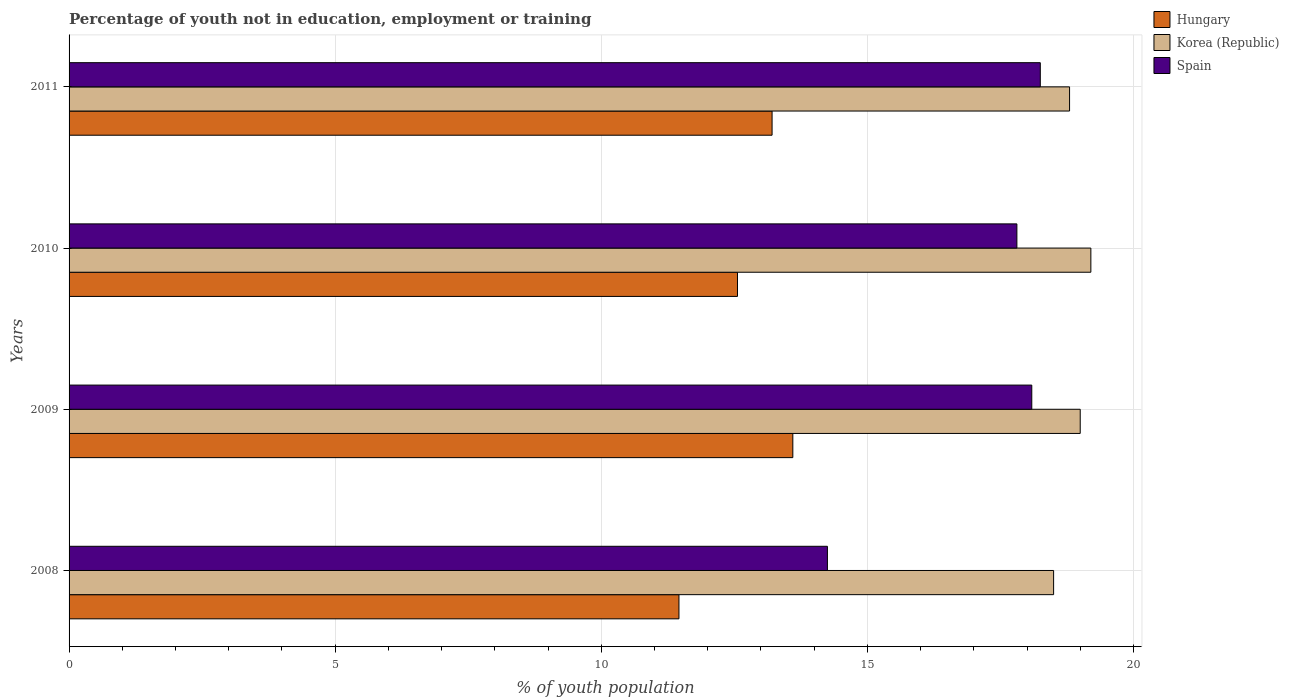How many different coloured bars are there?
Provide a short and direct response. 3. How many groups of bars are there?
Make the answer very short. 4. Are the number of bars per tick equal to the number of legend labels?
Provide a short and direct response. Yes. What is the label of the 2nd group of bars from the top?
Provide a succinct answer. 2010. In how many cases, is the number of bars for a given year not equal to the number of legend labels?
Provide a short and direct response. 0. Across all years, what is the maximum percentage of unemployed youth population in in Hungary?
Offer a very short reply. 13.6. Across all years, what is the minimum percentage of unemployed youth population in in Spain?
Your answer should be compact. 14.25. In which year was the percentage of unemployed youth population in in Spain minimum?
Offer a very short reply. 2008. What is the total percentage of unemployed youth population in in Korea (Republic) in the graph?
Offer a terse response. 75.5. What is the difference between the percentage of unemployed youth population in in Hungary in 2009 and that in 2011?
Your answer should be compact. 0.39. What is the difference between the percentage of unemployed youth population in in Hungary in 2010 and the percentage of unemployed youth population in in Korea (Republic) in 2008?
Provide a short and direct response. -5.94. What is the average percentage of unemployed youth population in in Spain per year?
Keep it short and to the point. 17.1. In the year 2011, what is the difference between the percentage of unemployed youth population in in Hungary and percentage of unemployed youth population in in Korea (Republic)?
Your answer should be very brief. -5.59. In how many years, is the percentage of unemployed youth population in in Spain greater than 15 %?
Keep it short and to the point. 3. What is the ratio of the percentage of unemployed youth population in in Hungary in 2008 to that in 2011?
Offer a very short reply. 0.87. Is the percentage of unemployed youth population in in Hungary in 2008 less than that in 2009?
Offer a very short reply. Yes. What is the difference between the highest and the second highest percentage of unemployed youth population in in Spain?
Your answer should be compact. 0.16. What is the difference between the highest and the lowest percentage of unemployed youth population in in Hungary?
Provide a short and direct response. 2.14. What does the 3rd bar from the top in 2008 represents?
Provide a short and direct response. Hungary. What does the 3rd bar from the bottom in 2008 represents?
Give a very brief answer. Spain. How many bars are there?
Make the answer very short. 12. Are all the bars in the graph horizontal?
Offer a terse response. Yes. How many years are there in the graph?
Provide a succinct answer. 4. Does the graph contain grids?
Your response must be concise. Yes. How many legend labels are there?
Offer a very short reply. 3. How are the legend labels stacked?
Offer a terse response. Vertical. What is the title of the graph?
Provide a short and direct response. Percentage of youth not in education, employment or training. Does "French Polynesia" appear as one of the legend labels in the graph?
Offer a very short reply. No. What is the label or title of the X-axis?
Provide a succinct answer. % of youth population. What is the % of youth population of Hungary in 2008?
Make the answer very short. 11.46. What is the % of youth population in Korea (Republic) in 2008?
Keep it short and to the point. 18.5. What is the % of youth population in Spain in 2008?
Give a very brief answer. 14.25. What is the % of youth population of Hungary in 2009?
Your response must be concise. 13.6. What is the % of youth population in Korea (Republic) in 2009?
Give a very brief answer. 19. What is the % of youth population of Spain in 2009?
Keep it short and to the point. 18.09. What is the % of youth population of Hungary in 2010?
Make the answer very short. 12.56. What is the % of youth population in Korea (Republic) in 2010?
Your response must be concise. 19.2. What is the % of youth population in Spain in 2010?
Your answer should be very brief. 17.81. What is the % of youth population of Hungary in 2011?
Your response must be concise. 13.21. What is the % of youth population of Korea (Republic) in 2011?
Ensure brevity in your answer.  18.8. What is the % of youth population in Spain in 2011?
Give a very brief answer. 18.25. Across all years, what is the maximum % of youth population of Hungary?
Provide a succinct answer. 13.6. Across all years, what is the maximum % of youth population of Korea (Republic)?
Your response must be concise. 19.2. Across all years, what is the maximum % of youth population in Spain?
Make the answer very short. 18.25. Across all years, what is the minimum % of youth population of Hungary?
Your answer should be very brief. 11.46. Across all years, what is the minimum % of youth population of Spain?
Your answer should be very brief. 14.25. What is the total % of youth population of Hungary in the graph?
Give a very brief answer. 50.83. What is the total % of youth population in Korea (Republic) in the graph?
Make the answer very short. 75.5. What is the total % of youth population of Spain in the graph?
Your answer should be compact. 68.4. What is the difference between the % of youth population in Hungary in 2008 and that in 2009?
Your answer should be compact. -2.14. What is the difference between the % of youth population of Spain in 2008 and that in 2009?
Offer a terse response. -3.84. What is the difference between the % of youth population in Hungary in 2008 and that in 2010?
Your answer should be very brief. -1.1. What is the difference between the % of youth population in Korea (Republic) in 2008 and that in 2010?
Make the answer very short. -0.7. What is the difference between the % of youth population of Spain in 2008 and that in 2010?
Ensure brevity in your answer.  -3.56. What is the difference between the % of youth population in Hungary in 2008 and that in 2011?
Give a very brief answer. -1.75. What is the difference between the % of youth population in Korea (Republic) in 2008 and that in 2011?
Provide a short and direct response. -0.3. What is the difference between the % of youth population of Spain in 2008 and that in 2011?
Keep it short and to the point. -4. What is the difference between the % of youth population of Korea (Republic) in 2009 and that in 2010?
Make the answer very short. -0.2. What is the difference between the % of youth population of Spain in 2009 and that in 2010?
Provide a succinct answer. 0.28. What is the difference between the % of youth population of Hungary in 2009 and that in 2011?
Ensure brevity in your answer.  0.39. What is the difference between the % of youth population in Spain in 2009 and that in 2011?
Provide a short and direct response. -0.16. What is the difference between the % of youth population of Hungary in 2010 and that in 2011?
Ensure brevity in your answer.  -0.65. What is the difference between the % of youth population in Korea (Republic) in 2010 and that in 2011?
Offer a terse response. 0.4. What is the difference between the % of youth population of Spain in 2010 and that in 2011?
Your response must be concise. -0.44. What is the difference between the % of youth population of Hungary in 2008 and the % of youth population of Korea (Republic) in 2009?
Your response must be concise. -7.54. What is the difference between the % of youth population of Hungary in 2008 and the % of youth population of Spain in 2009?
Provide a short and direct response. -6.63. What is the difference between the % of youth population in Korea (Republic) in 2008 and the % of youth population in Spain in 2009?
Your answer should be very brief. 0.41. What is the difference between the % of youth population in Hungary in 2008 and the % of youth population in Korea (Republic) in 2010?
Make the answer very short. -7.74. What is the difference between the % of youth population of Hungary in 2008 and the % of youth population of Spain in 2010?
Offer a terse response. -6.35. What is the difference between the % of youth population of Korea (Republic) in 2008 and the % of youth population of Spain in 2010?
Provide a short and direct response. 0.69. What is the difference between the % of youth population in Hungary in 2008 and the % of youth population in Korea (Republic) in 2011?
Provide a succinct answer. -7.34. What is the difference between the % of youth population of Hungary in 2008 and the % of youth population of Spain in 2011?
Keep it short and to the point. -6.79. What is the difference between the % of youth population of Hungary in 2009 and the % of youth population of Spain in 2010?
Provide a short and direct response. -4.21. What is the difference between the % of youth population of Korea (Republic) in 2009 and the % of youth population of Spain in 2010?
Give a very brief answer. 1.19. What is the difference between the % of youth population of Hungary in 2009 and the % of youth population of Korea (Republic) in 2011?
Provide a succinct answer. -5.2. What is the difference between the % of youth population in Hungary in 2009 and the % of youth population in Spain in 2011?
Make the answer very short. -4.65. What is the difference between the % of youth population in Korea (Republic) in 2009 and the % of youth population in Spain in 2011?
Ensure brevity in your answer.  0.75. What is the difference between the % of youth population of Hungary in 2010 and the % of youth population of Korea (Republic) in 2011?
Give a very brief answer. -6.24. What is the difference between the % of youth population in Hungary in 2010 and the % of youth population in Spain in 2011?
Your answer should be compact. -5.69. What is the average % of youth population in Hungary per year?
Make the answer very short. 12.71. What is the average % of youth population in Korea (Republic) per year?
Offer a very short reply. 18.88. In the year 2008, what is the difference between the % of youth population in Hungary and % of youth population in Korea (Republic)?
Provide a short and direct response. -7.04. In the year 2008, what is the difference between the % of youth population in Hungary and % of youth population in Spain?
Your response must be concise. -2.79. In the year 2008, what is the difference between the % of youth population of Korea (Republic) and % of youth population of Spain?
Offer a terse response. 4.25. In the year 2009, what is the difference between the % of youth population of Hungary and % of youth population of Spain?
Your answer should be compact. -4.49. In the year 2009, what is the difference between the % of youth population of Korea (Republic) and % of youth population of Spain?
Provide a succinct answer. 0.91. In the year 2010, what is the difference between the % of youth population of Hungary and % of youth population of Korea (Republic)?
Keep it short and to the point. -6.64. In the year 2010, what is the difference between the % of youth population in Hungary and % of youth population in Spain?
Your response must be concise. -5.25. In the year 2010, what is the difference between the % of youth population of Korea (Republic) and % of youth population of Spain?
Ensure brevity in your answer.  1.39. In the year 2011, what is the difference between the % of youth population of Hungary and % of youth population of Korea (Republic)?
Your answer should be very brief. -5.59. In the year 2011, what is the difference between the % of youth population of Hungary and % of youth population of Spain?
Your answer should be very brief. -5.04. In the year 2011, what is the difference between the % of youth population in Korea (Republic) and % of youth population in Spain?
Your response must be concise. 0.55. What is the ratio of the % of youth population in Hungary in 2008 to that in 2009?
Your answer should be very brief. 0.84. What is the ratio of the % of youth population in Korea (Republic) in 2008 to that in 2009?
Make the answer very short. 0.97. What is the ratio of the % of youth population in Spain in 2008 to that in 2009?
Your answer should be compact. 0.79. What is the ratio of the % of youth population of Hungary in 2008 to that in 2010?
Make the answer very short. 0.91. What is the ratio of the % of youth population of Korea (Republic) in 2008 to that in 2010?
Your answer should be very brief. 0.96. What is the ratio of the % of youth population of Spain in 2008 to that in 2010?
Provide a short and direct response. 0.8. What is the ratio of the % of youth population of Hungary in 2008 to that in 2011?
Give a very brief answer. 0.87. What is the ratio of the % of youth population of Korea (Republic) in 2008 to that in 2011?
Keep it short and to the point. 0.98. What is the ratio of the % of youth population of Spain in 2008 to that in 2011?
Offer a very short reply. 0.78. What is the ratio of the % of youth population of Hungary in 2009 to that in 2010?
Your answer should be compact. 1.08. What is the ratio of the % of youth population of Korea (Republic) in 2009 to that in 2010?
Your response must be concise. 0.99. What is the ratio of the % of youth population of Spain in 2009 to that in 2010?
Offer a terse response. 1.02. What is the ratio of the % of youth population of Hungary in 2009 to that in 2011?
Provide a short and direct response. 1.03. What is the ratio of the % of youth population in Korea (Republic) in 2009 to that in 2011?
Your answer should be very brief. 1.01. What is the ratio of the % of youth population of Spain in 2009 to that in 2011?
Ensure brevity in your answer.  0.99. What is the ratio of the % of youth population of Hungary in 2010 to that in 2011?
Ensure brevity in your answer.  0.95. What is the ratio of the % of youth population of Korea (Republic) in 2010 to that in 2011?
Offer a very short reply. 1.02. What is the ratio of the % of youth population of Spain in 2010 to that in 2011?
Your response must be concise. 0.98. What is the difference between the highest and the second highest % of youth population in Hungary?
Your response must be concise. 0.39. What is the difference between the highest and the second highest % of youth population of Korea (Republic)?
Your answer should be very brief. 0.2. What is the difference between the highest and the second highest % of youth population in Spain?
Make the answer very short. 0.16. What is the difference between the highest and the lowest % of youth population of Hungary?
Provide a succinct answer. 2.14. What is the difference between the highest and the lowest % of youth population of Korea (Republic)?
Give a very brief answer. 0.7. What is the difference between the highest and the lowest % of youth population in Spain?
Keep it short and to the point. 4. 